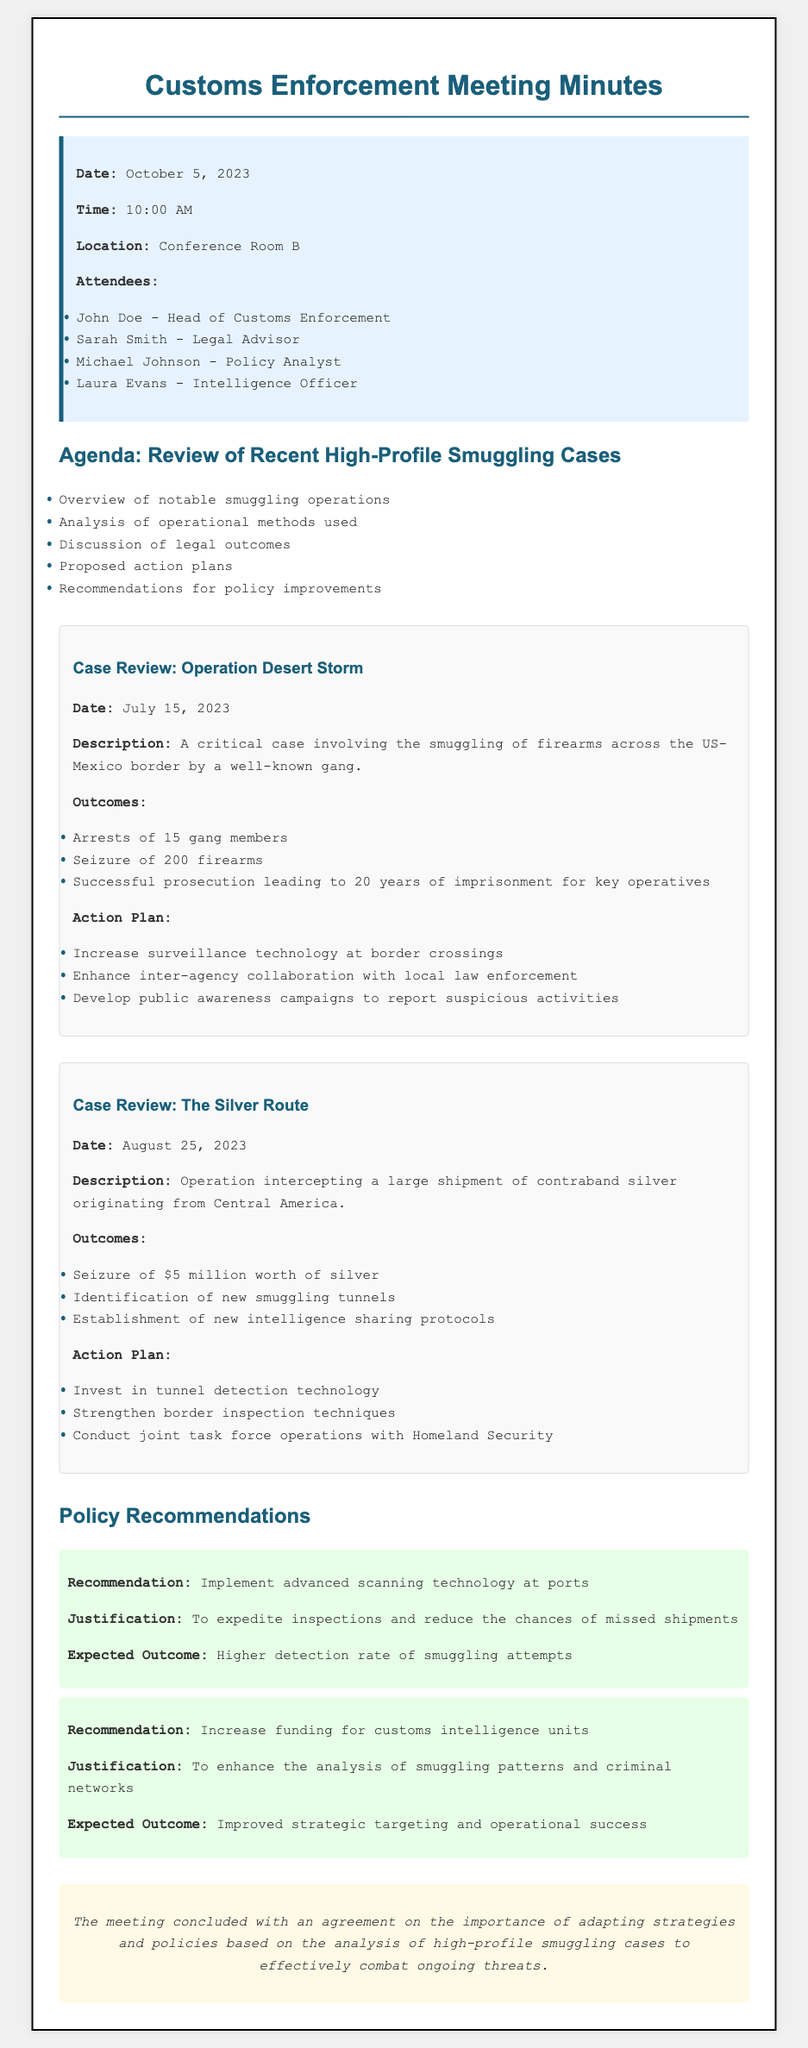What was the date of the meeting? The date of the meeting is provided in the meeting details section, which states it was on October 5, 2023.
Answer: October 5, 2023 Who is the Head of Customs Enforcement? The document lists John Doe as the Head of Customs Enforcement in the attendees section.
Answer: John Doe What was seized in Operation Desert Storm? The outcomes section for Operation Desert Storm mentions the seizure of 200 firearms.
Answer: 200 firearms How much was the worth of silver in The Silver Route case? The outcomes for The Silver Route case specify a seizure of $5 million worth of silver.
Answer: $5 million What is one of the policy recommendations? The policy recommendations section includes multiple recommendations; one of them is to implement advanced scanning technology at ports.
Answer: Implement advanced scanning technology at ports What was the key outcome of Operation Desert Storm? The outcomes listed indicate that one key result was the successful prosecution leading to 20 years of imprisonment for key operatives.
Answer: Successful prosecution leading to 20 years of imprisonment for key operatives What was the time of the meeting? The meeting details specify that it started at 10:00 AM.
Answer: 10:00 AM What technology is suggested for enhancing border inspection? The action plan for The Silver Route case suggests investing in tunnel detection technology to enhance border inspection.
Answer: Invest in tunnel detection technology 